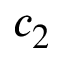Convert formula to latex. <formula><loc_0><loc_0><loc_500><loc_500>c _ { 2 }</formula> 